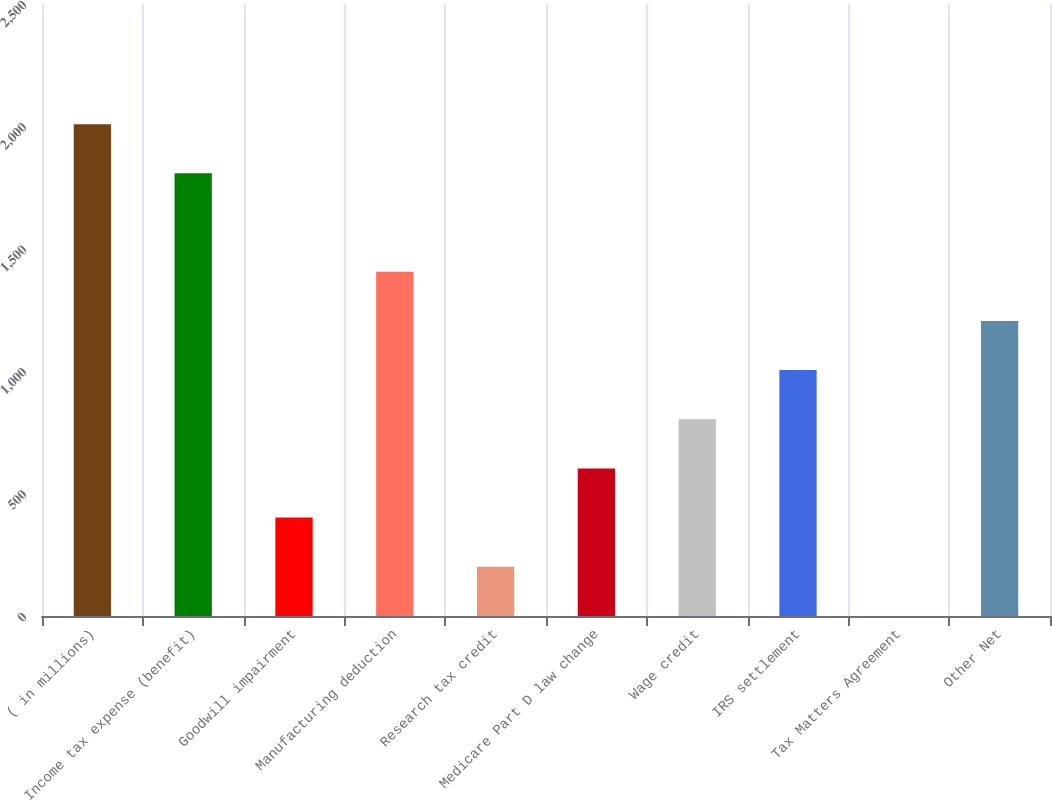Convert chart. <chart><loc_0><loc_0><loc_500><loc_500><bar_chart><fcel>( in millions)<fcel>Income tax expense (benefit)<fcel>Goodwill impairment<fcel>Manufacturing deduction<fcel>Research tax credit<fcel>Medicare Part D law change<fcel>Wage credit<fcel>IRS settlement<fcel>Tax Matters Agreement<fcel>Other Net<nl><fcel>2009.03<fcel>1808.14<fcel>401.91<fcel>1406.36<fcel>201.02<fcel>602.8<fcel>803.69<fcel>1004.58<fcel>0.13<fcel>1205.47<nl></chart> 